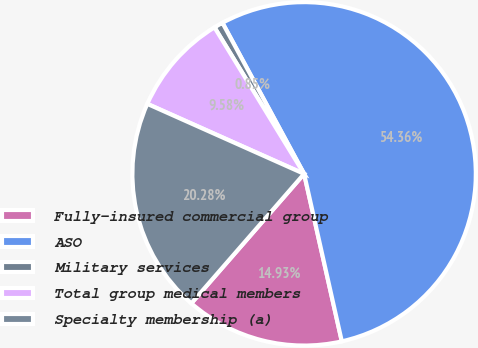Convert chart to OTSL. <chart><loc_0><loc_0><loc_500><loc_500><pie_chart><fcel>Fully-insured commercial group<fcel>ASO<fcel>Military services<fcel>Total group medical members<fcel>Specialty membership (a)<nl><fcel>14.93%<fcel>54.37%<fcel>0.85%<fcel>9.58%<fcel>20.28%<nl></chart> 